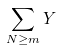<formula> <loc_0><loc_0><loc_500><loc_500>\sum _ { N \geq m } { Y }</formula> 